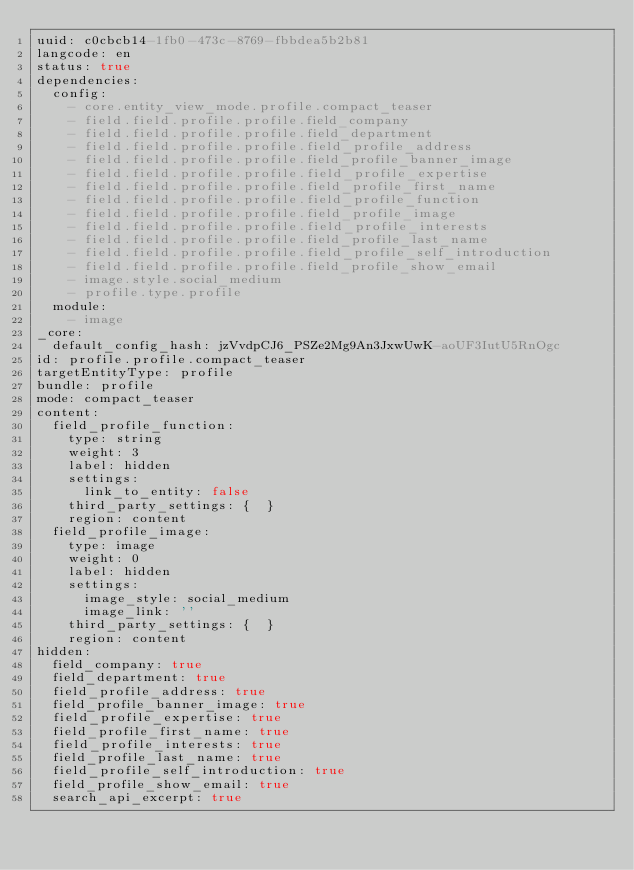Convert code to text. <code><loc_0><loc_0><loc_500><loc_500><_YAML_>uuid: c0cbcb14-1fb0-473c-8769-fbbdea5b2b81
langcode: en
status: true
dependencies:
  config:
    - core.entity_view_mode.profile.compact_teaser
    - field.field.profile.profile.field_company
    - field.field.profile.profile.field_department
    - field.field.profile.profile.field_profile_address
    - field.field.profile.profile.field_profile_banner_image
    - field.field.profile.profile.field_profile_expertise
    - field.field.profile.profile.field_profile_first_name
    - field.field.profile.profile.field_profile_function
    - field.field.profile.profile.field_profile_image
    - field.field.profile.profile.field_profile_interests
    - field.field.profile.profile.field_profile_last_name
    - field.field.profile.profile.field_profile_self_introduction
    - field.field.profile.profile.field_profile_show_email
    - image.style.social_medium
    - profile.type.profile
  module:
    - image
_core:
  default_config_hash: jzVvdpCJ6_PSZe2Mg9An3JxwUwK-aoUF3IutU5RnOgc
id: profile.profile.compact_teaser
targetEntityType: profile
bundle: profile
mode: compact_teaser
content:
  field_profile_function:
    type: string
    weight: 3
    label: hidden
    settings:
      link_to_entity: false
    third_party_settings: {  }
    region: content
  field_profile_image:
    type: image
    weight: 0
    label: hidden
    settings:
      image_style: social_medium
      image_link: ''
    third_party_settings: {  }
    region: content
hidden:
  field_company: true
  field_department: true
  field_profile_address: true
  field_profile_banner_image: true
  field_profile_expertise: true
  field_profile_first_name: true
  field_profile_interests: true
  field_profile_last_name: true
  field_profile_self_introduction: true
  field_profile_show_email: true
  search_api_excerpt: true
</code> 